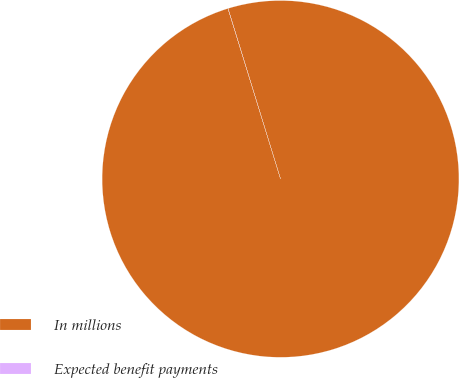Convert chart. <chart><loc_0><loc_0><loc_500><loc_500><pie_chart><fcel>In millions<fcel>Expected benefit payments<nl><fcel>99.99%<fcel>0.01%<nl></chart> 